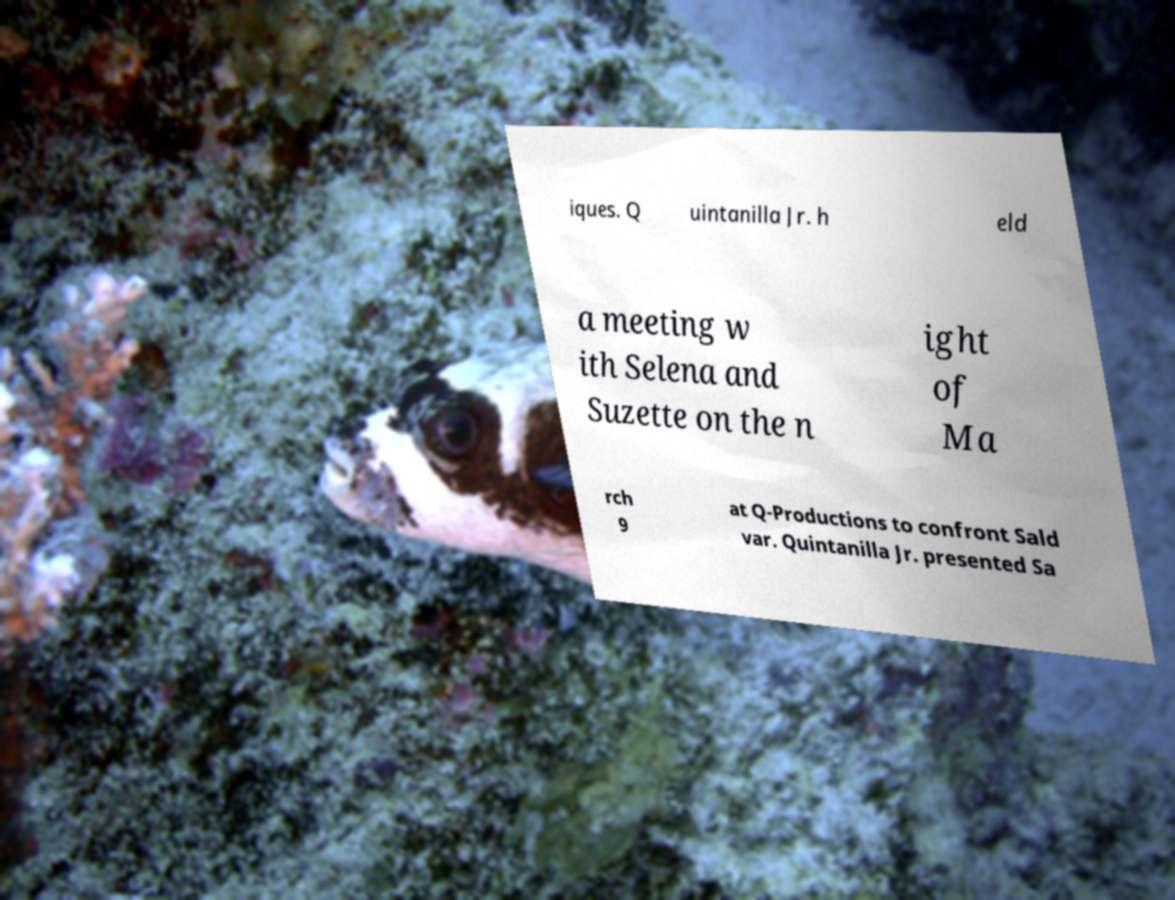There's text embedded in this image that I need extracted. Can you transcribe it verbatim? iques. Q uintanilla Jr. h eld a meeting w ith Selena and Suzette on the n ight of Ma rch 9 at Q-Productions to confront Sald var. Quintanilla Jr. presented Sa 